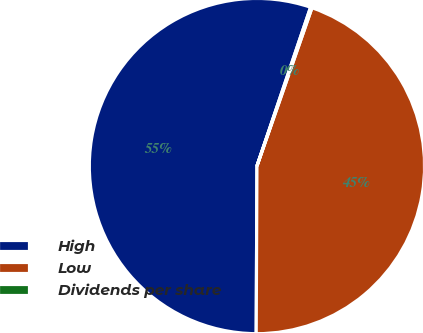Convert chart to OTSL. <chart><loc_0><loc_0><loc_500><loc_500><pie_chart><fcel>High<fcel>Low<fcel>Dividends per share<nl><fcel>55.12%<fcel>44.75%<fcel>0.14%<nl></chart> 